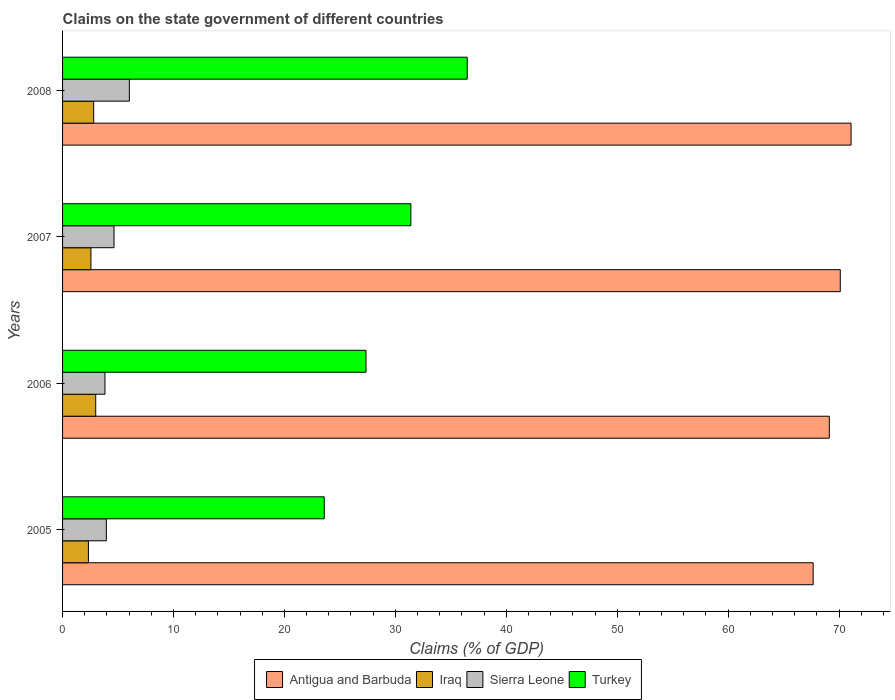How many groups of bars are there?
Offer a terse response. 4. Are the number of bars on each tick of the Y-axis equal?
Offer a terse response. Yes. What is the percentage of GDP claimed on the state government in Iraq in 2006?
Keep it short and to the point. 2.99. Across all years, what is the maximum percentage of GDP claimed on the state government in Iraq?
Make the answer very short. 2.99. Across all years, what is the minimum percentage of GDP claimed on the state government in Antigua and Barbuda?
Provide a short and direct response. 67.66. In which year was the percentage of GDP claimed on the state government in Sierra Leone maximum?
Your answer should be very brief. 2008. In which year was the percentage of GDP claimed on the state government in Sierra Leone minimum?
Give a very brief answer. 2006. What is the total percentage of GDP claimed on the state government in Iraq in the graph?
Make the answer very short. 10.68. What is the difference between the percentage of GDP claimed on the state government in Antigua and Barbuda in 2007 and that in 2008?
Offer a terse response. -0.97. What is the difference between the percentage of GDP claimed on the state government in Sierra Leone in 2008 and the percentage of GDP claimed on the state government in Iraq in 2007?
Ensure brevity in your answer.  3.47. What is the average percentage of GDP claimed on the state government in Iraq per year?
Provide a succinct answer. 2.67. In the year 2008, what is the difference between the percentage of GDP claimed on the state government in Turkey and percentage of GDP claimed on the state government in Sierra Leone?
Offer a terse response. 30.46. What is the ratio of the percentage of GDP claimed on the state government in Antigua and Barbuda in 2005 to that in 2007?
Provide a short and direct response. 0.97. Is the percentage of GDP claimed on the state government in Iraq in 2005 less than that in 2007?
Ensure brevity in your answer.  Yes. Is the difference between the percentage of GDP claimed on the state government in Turkey in 2006 and 2007 greater than the difference between the percentage of GDP claimed on the state government in Sierra Leone in 2006 and 2007?
Keep it short and to the point. No. What is the difference between the highest and the second highest percentage of GDP claimed on the state government in Sierra Leone?
Give a very brief answer. 1.38. What is the difference between the highest and the lowest percentage of GDP claimed on the state government in Sierra Leone?
Offer a very short reply. 2.2. In how many years, is the percentage of GDP claimed on the state government in Antigua and Barbuda greater than the average percentage of GDP claimed on the state government in Antigua and Barbuda taken over all years?
Provide a succinct answer. 2. Is it the case that in every year, the sum of the percentage of GDP claimed on the state government in Sierra Leone and percentage of GDP claimed on the state government in Antigua and Barbuda is greater than the sum of percentage of GDP claimed on the state government in Turkey and percentage of GDP claimed on the state government in Iraq?
Make the answer very short. Yes. What does the 4th bar from the top in 2008 represents?
Your response must be concise. Antigua and Barbuda. What does the 3rd bar from the bottom in 2008 represents?
Ensure brevity in your answer.  Sierra Leone. How many bars are there?
Your answer should be very brief. 16. Are the values on the major ticks of X-axis written in scientific E-notation?
Your response must be concise. No. Does the graph contain grids?
Offer a terse response. No. How are the legend labels stacked?
Your answer should be compact. Horizontal. What is the title of the graph?
Provide a succinct answer. Claims on the state government of different countries. Does "Middle East & North Africa (developing only)" appear as one of the legend labels in the graph?
Keep it short and to the point. No. What is the label or title of the X-axis?
Your answer should be very brief. Claims (% of GDP). What is the Claims (% of GDP) in Antigua and Barbuda in 2005?
Your response must be concise. 67.66. What is the Claims (% of GDP) in Iraq in 2005?
Your answer should be very brief. 2.33. What is the Claims (% of GDP) of Sierra Leone in 2005?
Your response must be concise. 3.95. What is the Claims (% of GDP) of Turkey in 2005?
Your answer should be compact. 23.59. What is the Claims (% of GDP) in Antigua and Barbuda in 2006?
Provide a succinct answer. 69.12. What is the Claims (% of GDP) in Iraq in 2006?
Offer a terse response. 2.99. What is the Claims (% of GDP) of Sierra Leone in 2006?
Keep it short and to the point. 3.82. What is the Claims (% of GDP) of Turkey in 2006?
Your answer should be compact. 27.35. What is the Claims (% of GDP) of Antigua and Barbuda in 2007?
Make the answer very short. 70.11. What is the Claims (% of GDP) in Iraq in 2007?
Your answer should be compact. 2.55. What is the Claims (% of GDP) of Sierra Leone in 2007?
Keep it short and to the point. 4.64. What is the Claims (% of GDP) of Turkey in 2007?
Make the answer very short. 31.4. What is the Claims (% of GDP) in Antigua and Barbuda in 2008?
Your response must be concise. 71.08. What is the Claims (% of GDP) in Iraq in 2008?
Provide a short and direct response. 2.8. What is the Claims (% of GDP) of Sierra Leone in 2008?
Your response must be concise. 6.02. What is the Claims (% of GDP) in Turkey in 2008?
Keep it short and to the point. 36.48. Across all years, what is the maximum Claims (% of GDP) of Antigua and Barbuda?
Provide a short and direct response. 71.08. Across all years, what is the maximum Claims (% of GDP) of Iraq?
Give a very brief answer. 2.99. Across all years, what is the maximum Claims (% of GDP) in Sierra Leone?
Provide a short and direct response. 6.02. Across all years, what is the maximum Claims (% of GDP) of Turkey?
Offer a terse response. 36.48. Across all years, what is the minimum Claims (% of GDP) of Antigua and Barbuda?
Ensure brevity in your answer.  67.66. Across all years, what is the minimum Claims (% of GDP) in Iraq?
Your answer should be compact. 2.33. Across all years, what is the minimum Claims (% of GDP) of Sierra Leone?
Offer a very short reply. 3.82. Across all years, what is the minimum Claims (% of GDP) of Turkey?
Offer a terse response. 23.59. What is the total Claims (% of GDP) in Antigua and Barbuda in the graph?
Offer a very short reply. 277.97. What is the total Claims (% of GDP) in Iraq in the graph?
Keep it short and to the point. 10.68. What is the total Claims (% of GDP) in Sierra Leone in the graph?
Your answer should be compact. 18.43. What is the total Claims (% of GDP) in Turkey in the graph?
Offer a terse response. 118.82. What is the difference between the Claims (% of GDP) in Antigua and Barbuda in 2005 and that in 2006?
Your response must be concise. -1.46. What is the difference between the Claims (% of GDP) of Iraq in 2005 and that in 2006?
Your answer should be very brief. -0.66. What is the difference between the Claims (% of GDP) in Sierra Leone in 2005 and that in 2006?
Keep it short and to the point. 0.13. What is the difference between the Claims (% of GDP) in Turkey in 2005 and that in 2006?
Give a very brief answer. -3.76. What is the difference between the Claims (% of GDP) in Antigua and Barbuda in 2005 and that in 2007?
Provide a succinct answer. -2.45. What is the difference between the Claims (% of GDP) in Iraq in 2005 and that in 2007?
Ensure brevity in your answer.  -0.22. What is the difference between the Claims (% of GDP) of Sierra Leone in 2005 and that in 2007?
Your answer should be compact. -0.69. What is the difference between the Claims (% of GDP) in Turkey in 2005 and that in 2007?
Give a very brief answer. -7.81. What is the difference between the Claims (% of GDP) of Antigua and Barbuda in 2005 and that in 2008?
Your response must be concise. -3.42. What is the difference between the Claims (% of GDP) of Iraq in 2005 and that in 2008?
Keep it short and to the point. -0.47. What is the difference between the Claims (% of GDP) of Sierra Leone in 2005 and that in 2008?
Ensure brevity in your answer.  -2.07. What is the difference between the Claims (% of GDP) in Turkey in 2005 and that in 2008?
Your answer should be very brief. -12.89. What is the difference between the Claims (% of GDP) in Antigua and Barbuda in 2006 and that in 2007?
Make the answer very short. -0.99. What is the difference between the Claims (% of GDP) in Iraq in 2006 and that in 2007?
Provide a succinct answer. 0.43. What is the difference between the Claims (% of GDP) of Sierra Leone in 2006 and that in 2007?
Your response must be concise. -0.81. What is the difference between the Claims (% of GDP) of Turkey in 2006 and that in 2007?
Provide a succinct answer. -4.04. What is the difference between the Claims (% of GDP) of Antigua and Barbuda in 2006 and that in 2008?
Offer a very short reply. -1.96. What is the difference between the Claims (% of GDP) in Iraq in 2006 and that in 2008?
Provide a succinct answer. 0.18. What is the difference between the Claims (% of GDP) of Sierra Leone in 2006 and that in 2008?
Keep it short and to the point. -2.2. What is the difference between the Claims (% of GDP) of Turkey in 2006 and that in 2008?
Make the answer very short. -9.12. What is the difference between the Claims (% of GDP) in Antigua and Barbuda in 2007 and that in 2008?
Your answer should be compact. -0.97. What is the difference between the Claims (% of GDP) of Iraq in 2007 and that in 2008?
Your answer should be compact. -0.25. What is the difference between the Claims (% of GDP) in Sierra Leone in 2007 and that in 2008?
Your response must be concise. -1.38. What is the difference between the Claims (% of GDP) of Turkey in 2007 and that in 2008?
Your answer should be compact. -5.08. What is the difference between the Claims (% of GDP) of Antigua and Barbuda in 2005 and the Claims (% of GDP) of Iraq in 2006?
Offer a terse response. 64.67. What is the difference between the Claims (% of GDP) of Antigua and Barbuda in 2005 and the Claims (% of GDP) of Sierra Leone in 2006?
Offer a very short reply. 63.84. What is the difference between the Claims (% of GDP) in Antigua and Barbuda in 2005 and the Claims (% of GDP) in Turkey in 2006?
Make the answer very short. 40.31. What is the difference between the Claims (% of GDP) in Iraq in 2005 and the Claims (% of GDP) in Sierra Leone in 2006?
Give a very brief answer. -1.49. What is the difference between the Claims (% of GDP) of Iraq in 2005 and the Claims (% of GDP) of Turkey in 2006?
Give a very brief answer. -25.02. What is the difference between the Claims (% of GDP) in Sierra Leone in 2005 and the Claims (% of GDP) in Turkey in 2006?
Make the answer very short. -23.41. What is the difference between the Claims (% of GDP) of Antigua and Barbuda in 2005 and the Claims (% of GDP) of Iraq in 2007?
Your response must be concise. 65.11. What is the difference between the Claims (% of GDP) in Antigua and Barbuda in 2005 and the Claims (% of GDP) in Sierra Leone in 2007?
Your answer should be compact. 63.03. What is the difference between the Claims (% of GDP) of Antigua and Barbuda in 2005 and the Claims (% of GDP) of Turkey in 2007?
Offer a terse response. 36.26. What is the difference between the Claims (% of GDP) of Iraq in 2005 and the Claims (% of GDP) of Sierra Leone in 2007?
Provide a short and direct response. -2.31. What is the difference between the Claims (% of GDP) of Iraq in 2005 and the Claims (% of GDP) of Turkey in 2007?
Keep it short and to the point. -29.07. What is the difference between the Claims (% of GDP) in Sierra Leone in 2005 and the Claims (% of GDP) in Turkey in 2007?
Offer a terse response. -27.45. What is the difference between the Claims (% of GDP) of Antigua and Barbuda in 2005 and the Claims (% of GDP) of Iraq in 2008?
Provide a short and direct response. 64.86. What is the difference between the Claims (% of GDP) in Antigua and Barbuda in 2005 and the Claims (% of GDP) in Sierra Leone in 2008?
Give a very brief answer. 61.64. What is the difference between the Claims (% of GDP) of Antigua and Barbuda in 2005 and the Claims (% of GDP) of Turkey in 2008?
Provide a succinct answer. 31.18. What is the difference between the Claims (% of GDP) in Iraq in 2005 and the Claims (% of GDP) in Sierra Leone in 2008?
Offer a terse response. -3.69. What is the difference between the Claims (% of GDP) of Iraq in 2005 and the Claims (% of GDP) of Turkey in 2008?
Ensure brevity in your answer.  -34.15. What is the difference between the Claims (% of GDP) of Sierra Leone in 2005 and the Claims (% of GDP) of Turkey in 2008?
Provide a succinct answer. -32.53. What is the difference between the Claims (% of GDP) in Antigua and Barbuda in 2006 and the Claims (% of GDP) in Iraq in 2007?
Keep it short and to the point. 66.56. What is the difference between the Claims (% of GDP) of Antigua and Barbuda in 2006 and the Claims (% of GDP) of Sierra Leone in 2007?
Your response must be concise. 64.48. What is the difference between the Claims (% of GDP) in Antigua and Barbuda in 2006 and the Claims (% of GDP) in Turkey in 2007?
Ensure brevity in your answer.  37.72. What is the difference between the Claims (% of GDP) of Iraq in 2006 and the Claims (% of GDP) of Sierra Leone in 2007?
Provide a short and direct response. -1.65. What is the difference between the Claims (% of GDP) of Iraq in 2006 and the Claims (% of GDP) of Turkey in 2007?
Ensure brevity in your answer.  -28.41. What is the difference between the Claims (% of GDP) in Sierra Leone in 2006 and the Claims (% of GDP) in Turkey in 2007?
Provide a short and direct response. -27.58. What is the difference between the Claims (% of GDP) of Antigua and Barbuda in 2006 and the Claims (% of GDP) of Iraq in 2008?
Make the answer very short. 66.31. What is the difference between the Claims (% of GDP) of Antigua and Barbuda in 2006 and the Claims (% of GDP) of Sierra Leone in 2008?
Your answer should be very brief. 63.1. What is the difference between the Claims (% of GDP) of Antigua and Barbuda in 2006 and the Claims (% of GDP) of Turkey in 2008?
Offer a very short reply. 32.64. What is the difference between the Claims (% of GDP) in Iraq in 2006 and the Claims (% of GDP) in Sierra Leone in 2008?
Make the answer very short. -3.03. What is the difference between the Claims (% of GDP) in Iraq in 2006 and the Claims (% of GDP) in Turkey in 2008?
Ensure brevity in your answer.  -33.49. What is the difference between the Claims (% of GDP) of Sierra Leone in 2006 and the Claims (% of GDP) of Turkey in 2008?
Provide a short and direct response. -32.66. What is the difference between the Claims (% of GDP) in Antigua and Barbuda in 2007 and the Claims (% of GDP) in Iraq in 2008?
Give a very brief answer. 67.3. What is the difference between the Claims (% of GDP) in Antigua and Barbuda in 2007 and the Claims (% of GDP) in Sierra Leone in 2008?
Offer a very short reply. 64.09. What is the difference between the Claims (% of GDP) of Antigua and Barbuda in 2007 and the Claims (% of GDP) of Turkey in 2008?
Make the answer very short. 33.63. What is the difference between the Claims (% of GDP) of Iraq in 2007 and the Claims (% of GDP) of Sierra Leone in 2008?
Your answer should be very brief. -3.47. What is the difference between the Claims (% of GDP) in Iraq in 2007 and the Claims (% of GDP) in Turkey in 2008?
Your answer should be compact. -33.92. What is the difference between the Claims (% of GDP) in Sierra Leone in 2007 and the Claims (% of GDP) in Turkey in 2008?
Offer a very short reply. -31.84. What is the average Claims (% of GDP) in Antigua and Barbuda per year?
Give a very brief answer. 69.49. What is the average Claims (% of GDP) in Iraq per year?
Your answer should be compact. 2.67. What is the average Claims (% of GDP) in Sierra Leone per year?
Ensure brevity in your answer.  4.61. What is the average Claims (% of GDP) in Turkey per year?
Keep it short and to the point. 29.71. In the year 2005, what is the difference between the Claims (% of GDP) in Antigua and Barbuda and Claims (% of GDP) in Iraq?
Provide a succinct answer. 65.33. In the year 2005, what is the difference between the Claims (% of GDP) of Antigua and Barbuda and Claims (% of GDP) of Sierra Leone?
Your answer should be very brief. 63.71. In the year 2005, what is the difference between the Claims (% of GDP) in Antigua and Barbuda and Claims (% of GDP) in Turkey?
Provide a short and direct response. 44.07. In the year 2005, what is the difference between the Claims (% of GDP) of Iraq and Claims (% of GDP) of Sierra Leone?
Ensure brevity in your answer.  -1.62. In the year 2005, what is the difference between the Claims (% of GDP) in Iraq and Claims (% of GDP) in Turkey?
Your answer should be compact. -21.26. In the year 2005, what is the difference between the Claims (% of GDP) in Sierra Leone and Claims (% of GDP) in Turkey?
Your answer should be compact. -19.64. In the year 2006, what is the difference between the Claims (% of GDP) in Antigua and Barbuda and Claims (% of GDP) in Iraq?
Make the answer very short. 66.13. In the year 2006, what is the difference between the Claims (% of GDP) of Antigua and Barbuda and Claims (% of GDP) of Sierra Leone?
Your answer should be compact. 65.3. In the year 2006, what is the difference between the Claims (% of GDP) in Antigua and Barbuda and Claims (% of GDP) in Turkey?
Ensure brevity in your answer.  41.76. In the year 2006, what is the difference between the Claims (% of GDP) in Iraq and Claims (% of GDP) in Sierra Leone?
Provide a succinct answer. -0.83. In the year 2006, what is the difference between the Claims (% of GDP) of Iraq and Claims (% of GDP) of Turkey?
Give a very brief answer. -24.37. In the year 2006, what is the difference between the Claims (% of GDP) of Sierra Leone and Claims (% of GDP) of Turkey?
Keep it short and to the point. -23.53. In the year 2007, what is the difference between the Claims (% of GDP) in Antigua and Barbuda and Claims (% of GDP) in Iraq?
Ensure brevity in your answer.  67.55. In the year 2007, what is the difference between the Claims (% of GDP) of Antigua and Barbuda and Claims (% of GDP) of Sierra Leone?
Provide a short and direct response. 65.47. In the year 2007, what is the difference between the Claims (% of GDP) in Antigua and Barbuda and Claims (% of GDP) in Turkey?
Make the answer very short. 38.71. In the year 2007, what is the difference between the Claims (% of GDP) in Iraq and Claims (% of GDP) in Sierra Leone?
Provide a short and direct response. -2.08. In the year 2007, what is the difference between the Claims (% of GDP) in Iraq and Claims (% of GDP) in Turkey?
Your answer should be compact. -28.84. In the year 2007, what is the difference between the Claims (% of GDP) in Sierra Leone and Claims (% of GDP) in Turkey?
Provide a short and direct response. -26.76. In the year 2008, what is the difference between the Claims (% of GDP) of Antigua and Barbuda and Claims (% of GDP) of Iraq?
Give a very brief answer. 68.28. In the year 2008, what is the difference between the Claims (% of GDP) in Antigua and Barbuda and Claims (% of GDP) in Sierra Leone?
Keep it short and to the point. 65.06. In the year 2008, what is the difference between the Claims (% of GDP) of Antigua and Barbuda and Claims (% of GDP) of Turkey?
Your answer should be compact. 34.6. In the year 2008, what is the difference between the Claims (% of GDP) of Iraq and Claims (% of GDP) of Sierra Leone?
Your answer should be very brief. -3.22. In the year 2008, what is the difference between the Claims (% of GDP) of Iraq and Claims (% of GDP) of Turkey?
Ensure brevity in your answer.  -33.67. In the year 2008, what is the difference between the Claims (% of GDP) of Sierra Leone and Claims (% of GDP) of Turkey?
Make the answer very short. -30.46. What is the ratio of the Claims (% of GDP) in Antigua and Barbuda in 2005 to that in 2006?
Your answer should be very brief. 0.98. What is the ratio of the Claims (% of GDP) in Iraq in 2005 to that in 2006?
Ensure brevity in your answer.  0.78. What is the ratio of the Claims (% of GDP) of Sierra Leone in 2005 to that in 2006?
Ensure brevity in your answer.  1.03. What is the ratio of the Claims (% of GDP) of Turkey in 2005 to that in 2006?
Keep it short and to the point. 0.86. What is the ratio of the Claims (% of GDP) of Antigua and Barbuda in 2005 to that in 2007?
Offer a very short reply. 0.97. What is the ratio of the Claims (% of GDP) of Iraq in 2005 to that in 2007?
Your response must be concise. 0.91. What is the ratio of the Claims (% of GDP) of Sierra Leone in 2005 to that in 2007?
Give a very brief answer. 0.85. What is the ratio of the Claims (% of GDP) in Turkey in 2005 to that in 2007?
Offer a very short reply. 0.75. What is the ratio of the Claims (% of GDP) of Antigua and Barbuda in 2005 to that in 2008?
Ensure brevity in your answer.  0.95. What is the ratio of the Claims (% of GDP) in Iraq in 2005 to that in 2008?
Offer a very short reply. 0.83. What is the ratio of the Claims (% of GDP) in Sierra Leone in 2005 to that in 2008?
Ensure brevity in your answer.  0.66. What is the ratio of the Claims (% of GDP) in Turkey in 2005 to that in 2008?
Make the answer very short. 0.65. What is the ratio of the Claims (% of GDP) of Antigua and Barbuda in 2006 to that in 2007?
Provide a short and direct response. 0.99. What is the ratio of the Claims (% of GDP) in Iraq in 2006 to that in 2007?
Provide a succinct answer. 1.17. What is the ratio of the Claims (% of GDP) of Sierra Leone in 2006 to that in 2007?
Provide a short and direct response. 0.82. What is the ratio of the Claims (% of GDP) in Turkey in 2006 to that in 2007?
Keep it short and to the point. 0.87. What is the ratio of the Claims (% of GDP) of Antigua and Barbuda in 2006 to that in 2008?
Your answer should be compact. 0.97. What is the ratio of the Claims (% of GDP) of Iraq in 2006 to that in 2008?
Keep it short and to the point. 1.07. What is the ratio of the Claims (% of GDP) in Sierra Leone in 2006 to that in 2008?
Your response must be concise. 0.63. What is the ratio of the Claims (% of GDP) of Turkey in 2006 to that in 2008?
Your answer should be compact. 0.75. What is the ratio of the Claims (% of GDP) in Antigua and Barbuda in 2007 to that in 2008?
Ensure brevity in your answer.  0.99. What is the ratio of the Claims (% of GDP) of Iraq in 2007 to that in 2008?
Your answer should be very brief. 0.91. What is the ratio of the Claims (% of GDP) in Sierra Leone in 2007 to that in 2008?
Give a very brief answer. 0.77. What is the ratio of the Claims (% of GDP) of Turkey in 2007 to that in 2008?
Offer a very short reply. 0.86. What is the difference between the highest and the second highest Claims (% of GDP) in Antigua and Barbuda?
Ensure brevity in your answer.  0.97. What is the difference between the highest and the second highest Claims (% of GDP) of Iraq?
Offer a very short reply. 0.18. What is the difference between the highest and the second highest Claims (% of GDP) in Sierra Leone?
Offer a very short reply. 1.38. What is the difference between the highest and the second highest Claims (% of GDP) of Turkey?
Keep it short and to the point. 5.08. What is the difference between the highest and the lowest Claims (% of GDP) of Antigua and Barbuda?
Offer a terse response. 3.42. What is the difference between the highest and the lowest Claims (% of GDP) in Iraq?
Offer a very short reply. 0.66. What is the difference between the highest and the lowest Claims (% of GDP) of Sierra Leone?
Make the answer very short. 2.2. What is the difference between the highest and the lowest Claims (% of GDP) in Turkey?
Offer a terse response. 12.89. 